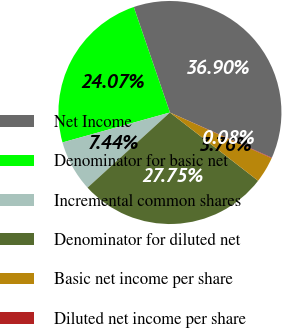Convert chart. <chart><loc_0><loc_0><loc_500><loc_500><pie_chart><fcel>Net Income<fcel>Denominator for basic net<fcel>Incremental common shares<fcel>Denominator for diluted net<fcel>Basic net income per share<fcel>Diluted net income per share<nl><fcel>36.9%<fcel>24.07%<fcel>7.44%<fcel>27.75%<fcel>3.76%<fcel>0.08%<nl></chart> 